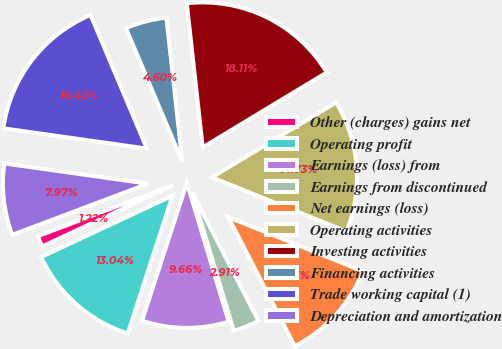Convert chart. <chart><loc_0><loc_0><loc_500><loc_500><pie_chart><fcel>Other (charges) gains net<fcel>Operating profit<fcel>Earnings (loss) from<fcel>Earnings from discontinued<fcel>Net earnings (loss)<fcel>Operating activities<fcel>Investing activities<fcel>Financing activities<fcel>Trade working capital (1)<fcel>Depreciation and amortization<nl><fcel>1.22%<fcel>13.04%<fcel>9.66%<fcel>2.91%<fcel>11.35%<fcel>14.73%<fcel>18.11%<fcel>4.6%<fcel>16.42%<fcel>7.97%<nl></chart> 